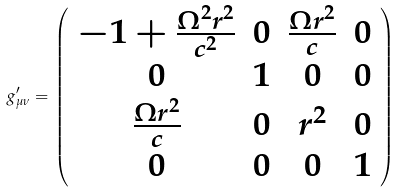<formula> <loc_0><loc_0><loc_500><loc_500>g _ { \mu \nu } ^ { \prime } = \left ( \begin{array} { c c c c } - 1 + \frac { \Omega ^ { 2 } { r } ^ { 2 } } { c ^ { 2 } } & 0 & \frac { \Omega { r } ^ { 2 } } { c } & 0 \\ 0 & 1 & 0 & 0 \\ \frac { \Omega { r } ^ { 2 } } { c } & 0 & { r } ^ { 2 } & 0 \\ 0 & 0 & 0 & 1 \end{array} \right )</formula> 